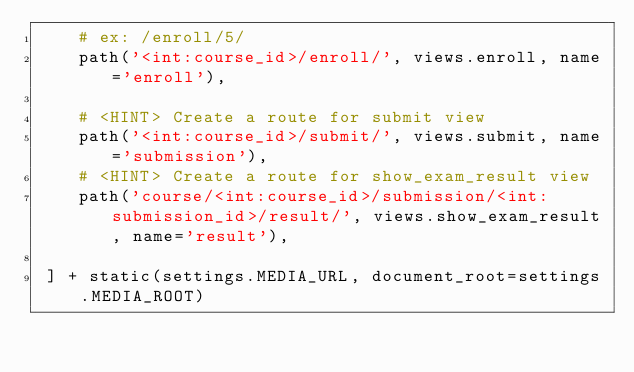Convert code to text. <code><loc_0><loc_0><loc_500><loc_500><_Python_>    # ex: /enroll/5/
    path('<int:course_id>/enroll/', views.enroll, name='enroll'),

    # <HINT> Create a route for submit view
    path('<int:course_id>/submit/', views.submit, name='submission'),
    # <HINT> Create a route for show_exam_result view
    path('course/<int:course_id>/submission/<int:submission_id>/result/', views.show_exam_result, name='result'),
    
 ] + static(settings.MEDIA_URL, document_root=settings.MEDIA_ROOT)</code> 